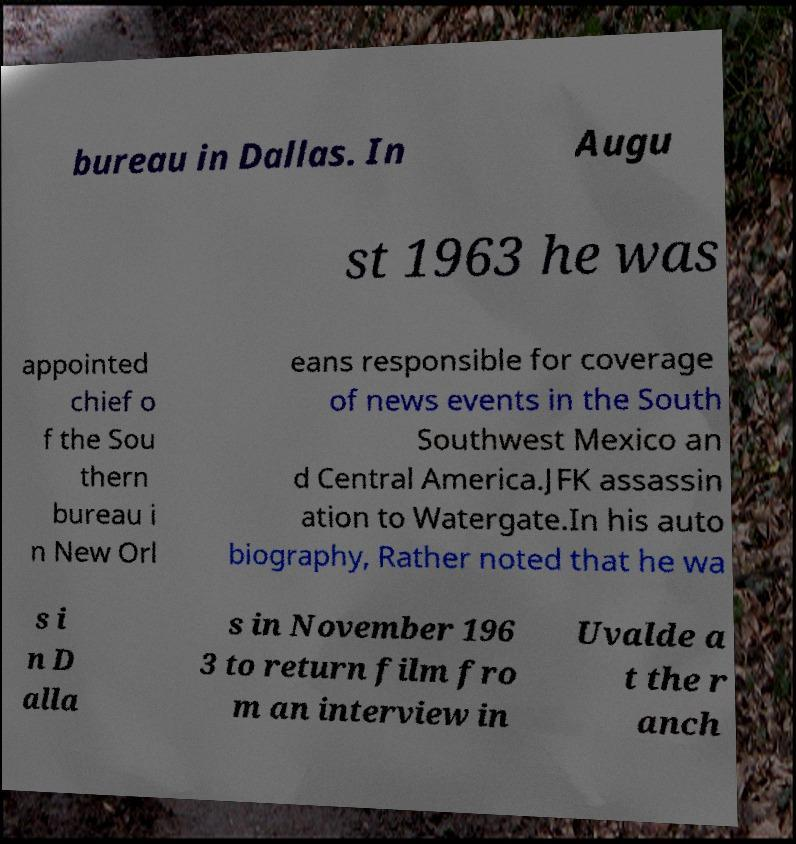For documentation purposes, I need the text within this image transcribed. Could you provide that? bureau in Dallas. In Augu st 1963 he was appointed chief o f the Sou thern bureau i n New Orl eans responsible for coverage of news events in the South Southwest Mexico an d Central America.JFK assassin ation to Watergate.In his auto biography, Rather noted that he wa s i n D alla s in November 196 3 to return film fro m an interview in Uvalde a t the r anch 